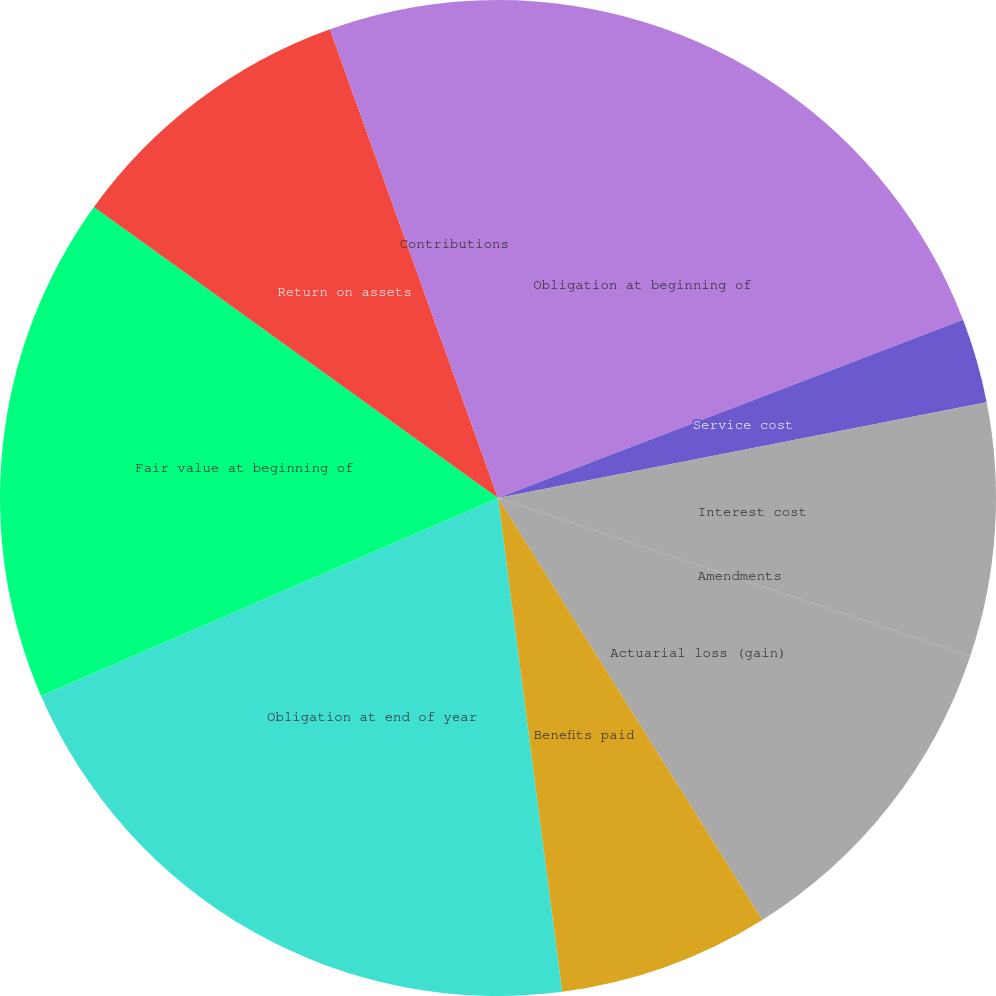Convert chart. <chart><loc_0><loc_0><loc_500><loc_500><pie_chart><fcel>Obligation at beginning of<fcel>Service cost<fcel>Interest cost<fcel>Amendments<fcel>Actuarial loss (gain)<fcel>Benefits paid<fcel>Obligation at end of year<fcel>Fair value at beginning of<fcel>Return on assets<fcel>Contributions<nl><fcel>19.18%<fcel>2.74%<fcel>8.22%<fcel>0.0%<fcel>10.96%<fcel>6.85%<fcel>20.55%<fcel>16.44%<fcel>9.59%<fcel>5.48%<nl></chart> 